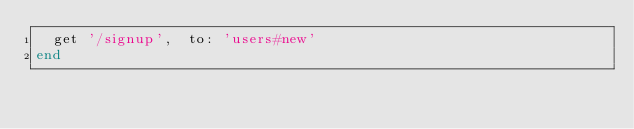Convert code to text. <code><loc_0><loc_0><loc_500><loc_500><_Ruby_>  get '/signup',  to: 'users#new'
end</code> 